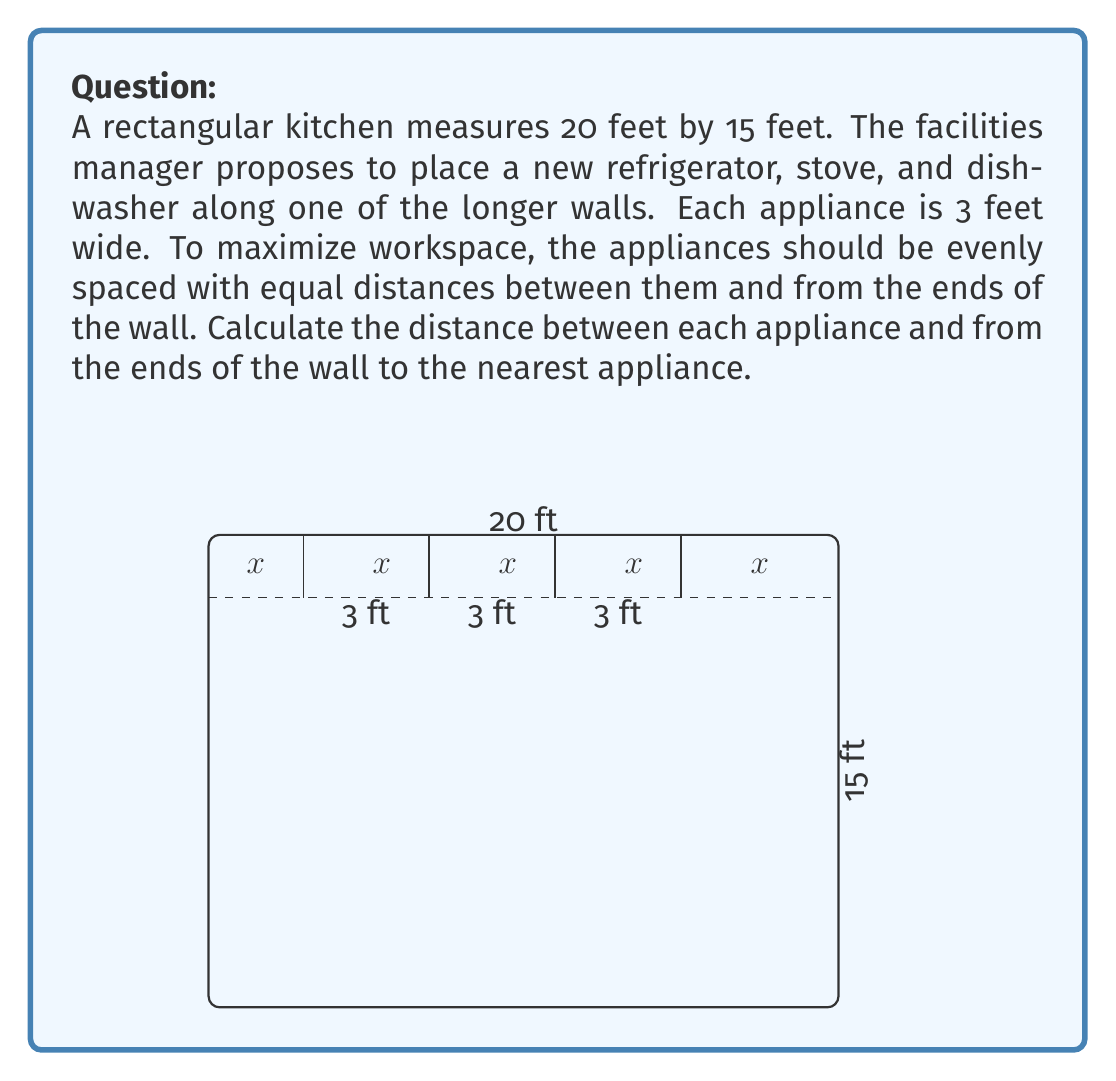Can you solve this math problem? To solve this problem, we'll follow these steps:

1) Let $x$ be the distance between appliances and from the ends of the wall to the nearest appliance.

2) The total length of the wall is 20 feet. We can express this as an equation:
   $$20 = x + 3 + x + 3 + x + 3 + x$$

3) Simplify the equation:
   $$20 = 4x + 9$$

4) Subtract 9 from both sides:
   $$11 = 4x$$

5) Divide both sides by 4:
   $$\frac{11}{4} = x$$

6) This fraction can be expressed as a decimal:
   $$x = 2.75$$

Therefore, the distance between each appliance and from the ends of the wall to the nearest appliance is 2.75 feet.

This arrangement ensures that the appliances are evenly spaced along the wall, maximizing the workspace between them and allowing for efficient movement in the kitchen.
Answer: 2.75 feet 